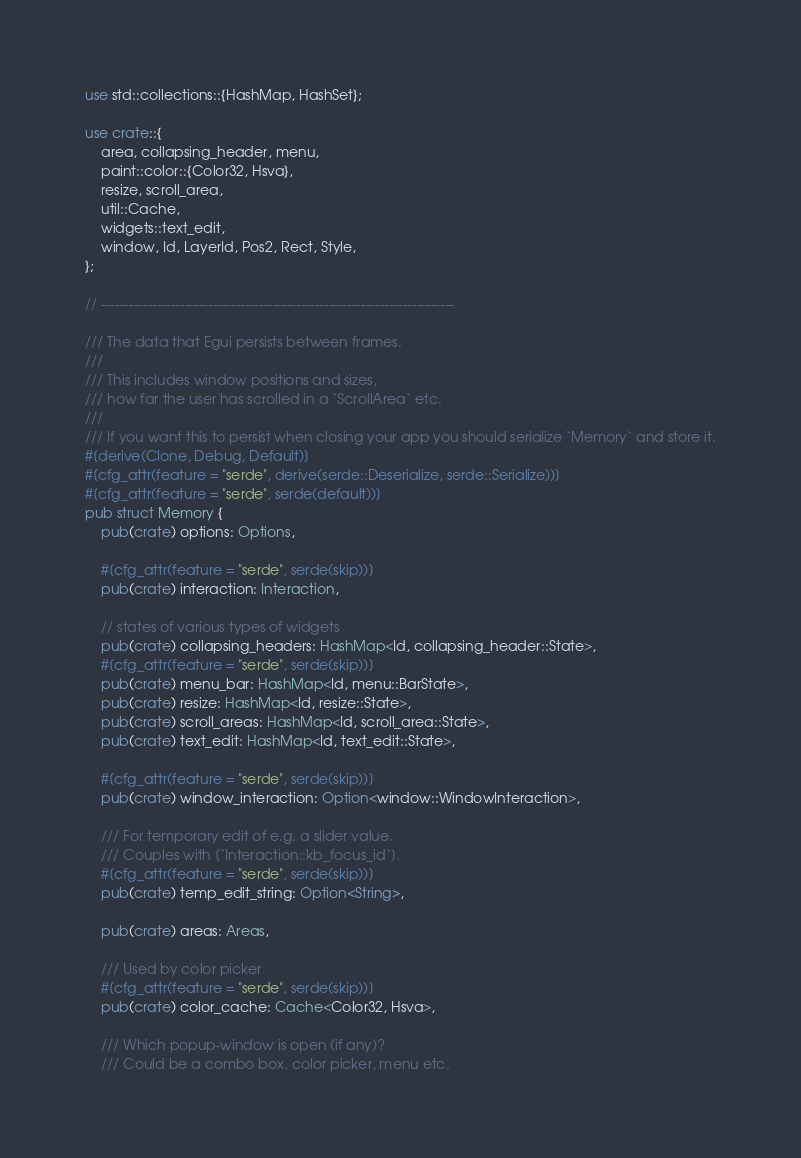Convert code to text. <code><loc_0><loc_0><loc_500><loc_500><_Rust_>use std::collections::{HashMap, HashSet};

use crate::{
    area, collapsing_header, menu,
    paint::color::{Color32, Hsva},
    resize, scroll_area,
    util::Cache,
    widgets::text_edit,
    window, Id, LayerId, Pos2, Rect, Style,
};

// ----------------------------------------------------------------------------

/// The data that Egui persists between frames.
///
/// This includes window positions and sizes,
/// how far the user has scrolled in a `ScrollArea` etc.
///
/// If you want this to persist when closing your app you should serialize `Memory` and store it.
#[derive(Clone, Debug, Default)]
#[cfg_attr(feature = "serde", derive(serde::Deserialize, serde::Serialize))]
#[cfg_attr(feature = "serde", serde(default))]
pub struct Memory {
    pub(crate) options: Options,

    #[cfg_attr(feature = "serde", serde(skip))]
    pub(crate) interaction: Interaction,

    // states of various types of widgets
    pub(crate) collapsing_headers: HashMap<Id, collapsing_header::State>,
    #[cfg_attr(feature = "serde", serde(skip))]
    pub(crate) menu_bar: HashMap<Id, menu::BarState>,
    pub(crate) resize: HashMap<Id, resize::State>,
    pub(crate) scroll_areas: HashMap<Id, scroll_area::State>,
    pub(crate) text_edit: HashMap<Id, text_edit::State>,

    #[cfg_attr(feature = "serde", serde(skip))]
    pub(crate) window_interaction: Option<window::WindowInteraction>,

    /// For temporary edit of e.g. a slider value.
    /// Couples with [`Interaction::kb_focus_id`].
    #[cfg_attr(feature = "serde", serde(skip))]
    pub(crate) temp_edit_string: Option<String>,

    pub(crate) areas: Areas,

    /// Used by color picker
    #[cfg_attr(feature = "serde", serde(skip))]
    pub(crate) color_cache: Cache<Color32, Hsva>,

    /// Which popup-window is open (if any)?
    /// Could be a combo box, color picker, menu etc.</code> 